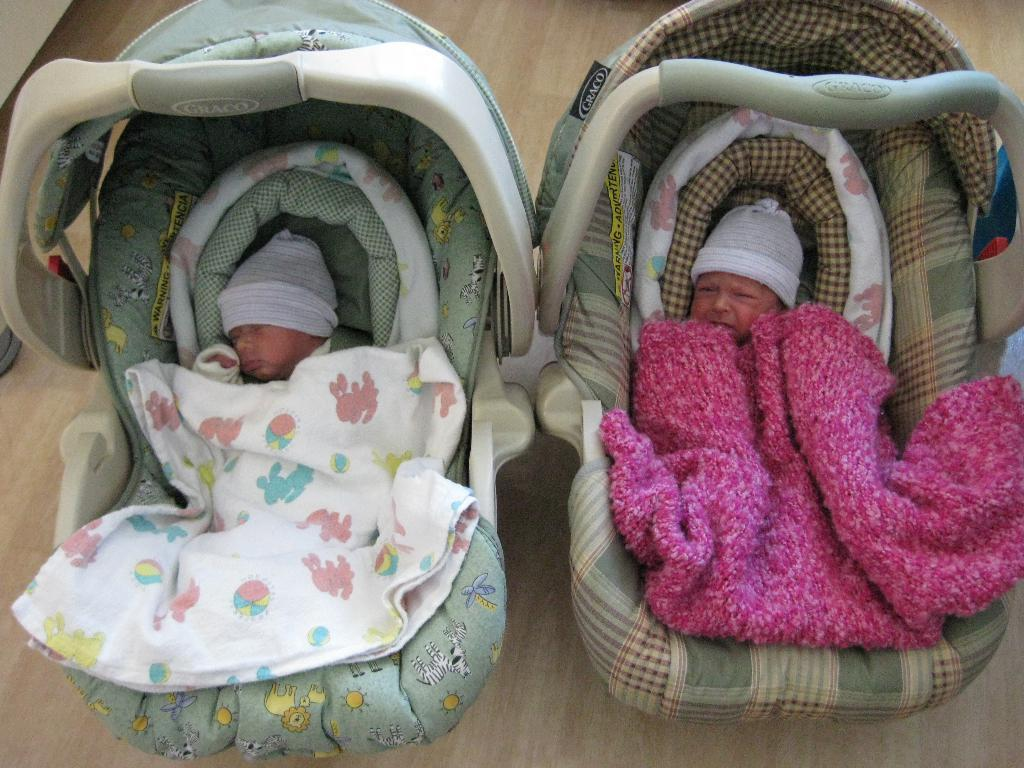How many baby seats are in the image? There are two baby seats in the image. How many babies are in the image? There are two babies in the image. What else is present in the image besides the baby seats and babies? There are two clothes in the image. What can be seen at the bottom of the image? The floor is visible at the bottom of the image. What type of note is the baby holding in the image? There are no notes present in the image; the babies are not holding anything. 